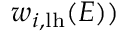Convert formula to latex. <formula><loc_0><loc_0><loc_500><loc_500>w _ { i , { l h } } ( E ) )</formula> 